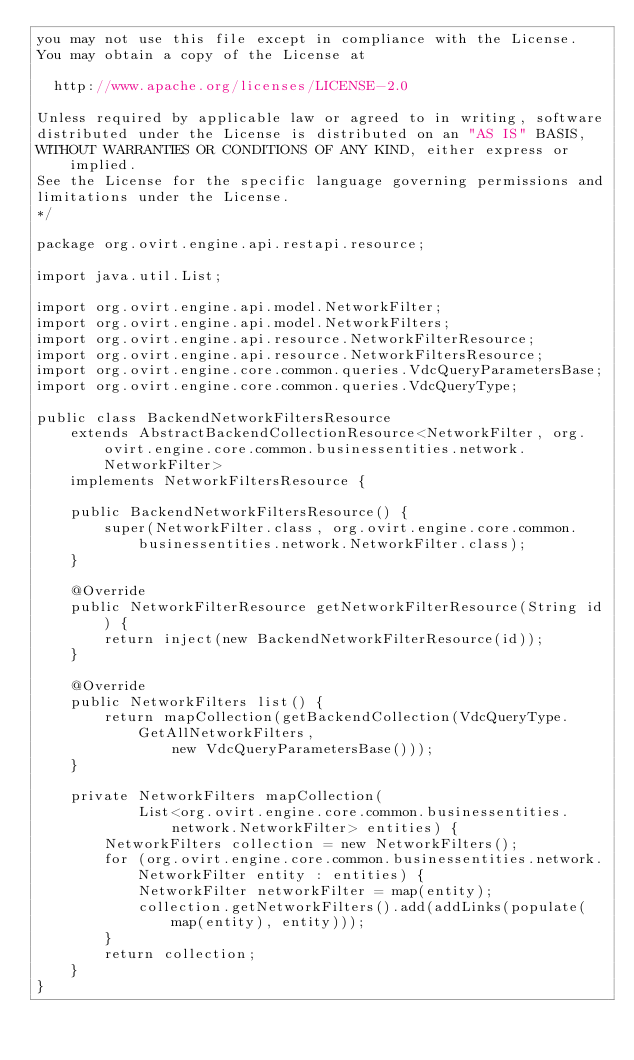Convert code to text. <code><loc_0><loc_0><loc_500><loc_500><_Java_>you may not use this file except in compliance with the License.
You may obtain a copy of the License at

  http://www.apache.org/licenses/LICENSE-2.0

Unless required by applicable law or agreed to in writing, software
distributed under the License is distributed on an "AS IS" BASIS,
WITHOUT WARRANTIES OR CONDITIONS OF ANY KIND, either express or implied.
See the License for the specific language governing permissions and
limitations under the License.
*/

package org.ovirt.engine.api.restapi.resource;

import java.util.List;

import org.ovirt.engine.api.model.NetworkFilter;
import org.ovirt.engine.api.model.NetworkFilters;
import org.ovirt.engine.api.resource.NetworkFilterResource;
import org.ovirt.engine.api.resource.NetworkFiltersResource;
import org.ovirt.engine.core.common.queries.VdcQueryParametersBase;
import org.ovirt.engine.core.common.queries.VdcQueryType;

public class BackendNetworkFiltersResource
    extends AbstractBackendCollectionResource<NetworkFilter, org.ovirt.engine.core.common.businessentities.network.NetworkFilter>
    implements NetworkFiltersResource {

    public BackendNetworkFiltersResource() {
        super(NetworkFilter.class, org.ovirt.engine.core.common.businessentities.network.NetworkFilter.class);
    }

    @Override
    public NetworkFilterResource getNetworkFilterResource(String id) {
        return inject(new BackendNetworkFilterResource(id));
    }

    @Override
    public NetworkFilters list() {
        return mapCollection(getBackendCollection(VdcQueryType.GetAllNetworkFilters,
                new VdcQueryParametersBase()));
    }

    private NetworkFilters mapCollection(
            List<org.ovirt.engine.core.common.businessentities.network.NetworkFilter> entities) {
        NetworkFilters collection = new NetworkFilters();
        for (org.ovirt.engine.core.common.businessentities.network.NetworkFilter entity : entities) {
            NetworkFilter networkFilter = map(entity);
            collection.getNetworkFilters().add(addLinks(populate(map(entity), entity)));
        }
        return collection;
    }
}
</code> 